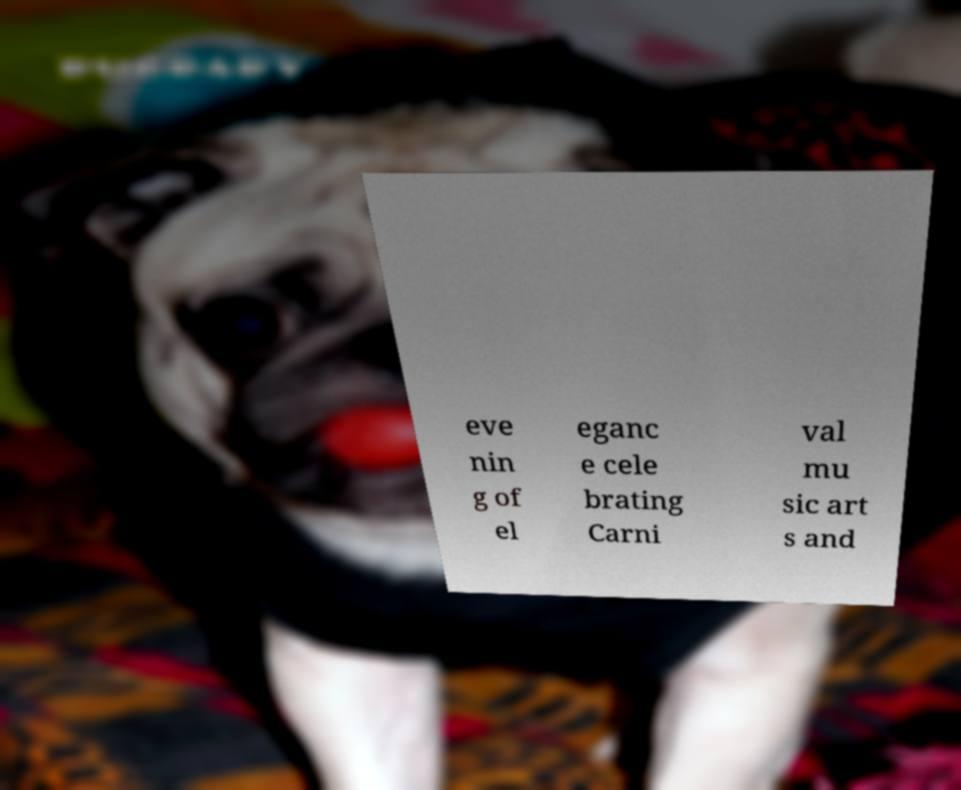Can you accurately transcribe the text from the provided image for me? eve nin g of el eganc e cele brating Carni val mu sic art s and 